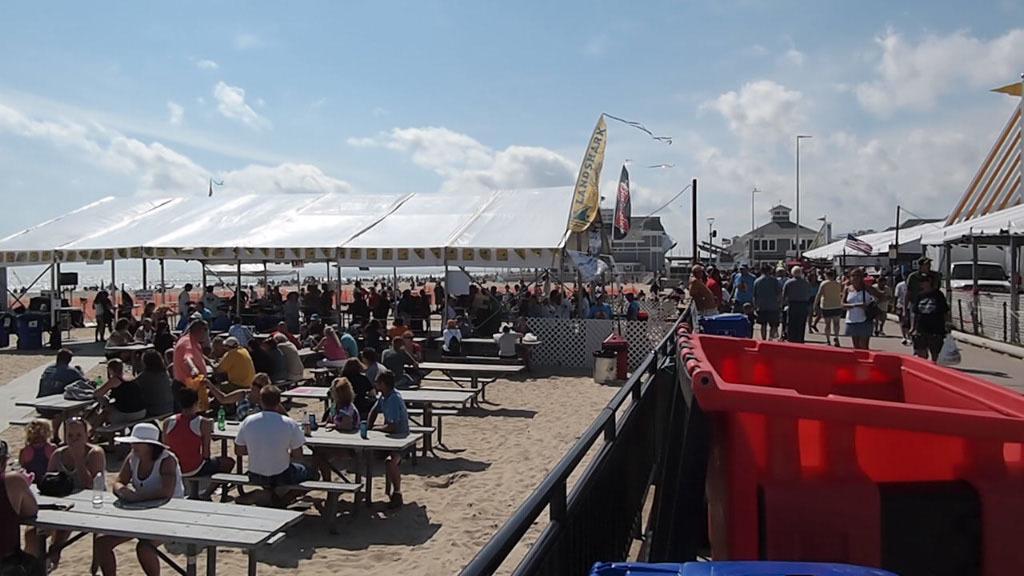Could you give a brief overview of what you see in this image? There are many persons sitting on benches. There are tables. In the background there is a tent. Also in the right side there is a basket. many people are walking on the road. There are some buildings. In the background there is sky with clouds. There are flags. 